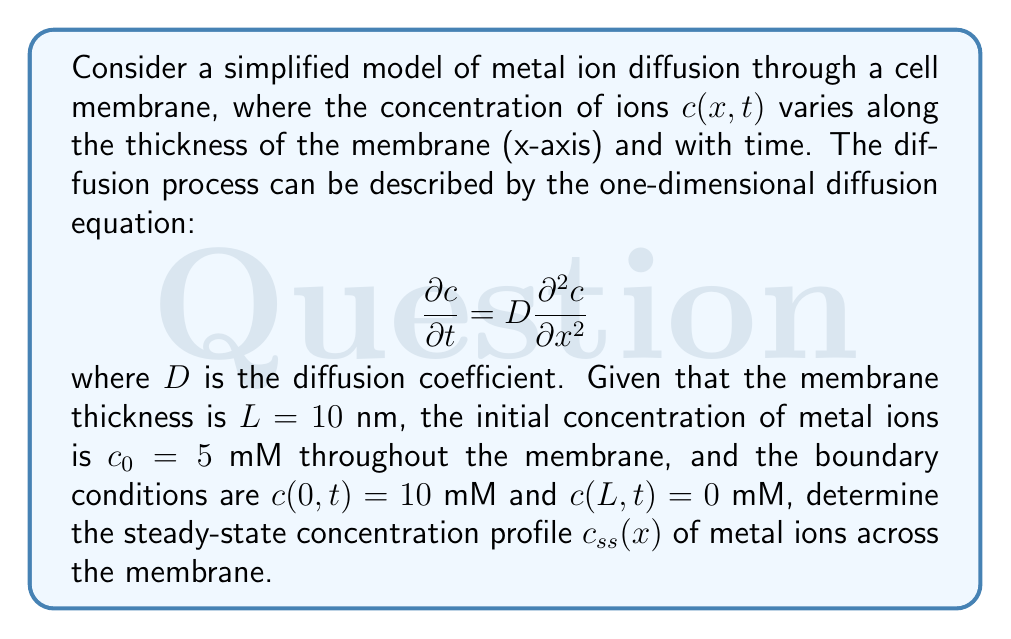Solve this math problem. To solve this problem, we'll follow these steps:

1) For the steady-state solution, the concentration doesn't change with time, so $\frac{\partial c}{\partial t} = 0$. The diffusion equation becomes:

   $$0 = D \frac{d^2 c_{ss}}{dx^2}$$

2) Integrating twice with respect to x:

   $$c_{ss}(x) = Ax + B$$

   where A and B are constants to be determined from the boundary conditions.

3) Apply the boundary conditions:
   At x = 0: $c_{ss}(0) = 10$ mM, so $B = 10$ mM
   At x = L: $c_{ss}(L) = 0$ mM, so $AL + 10 = 0$

4) Solve for A:
   $$A = -\frac{10}{L} = -\frac{10}{10} = -1 \text{ mM/nm}$$

5) The steady-state concentration profile is therefore:

   $$c_{ss}(x) = -x + 10$$

   where x is in nm and $c_{ss}$ is in mM.

This linear profile represents the equilibrium distribution of metal ions across the membrane thickness, with the concentration decreasing linearly from 10 mM at x = 0 to 0 mM at x = L.
Answer: $c_{ss}(x) = -x + 10$ mM, where x is in nm 